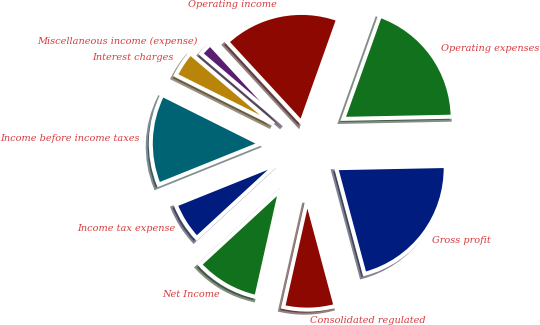<chart> <loc_0><loc_0><loc_500><loc_500><pie_chart><fcel>Gross profit<fcel>Operating expenses<fcel>Operating income<fcel>Miscellaneous income (expense)<fcel>Interest charges<fcel>Income before income taxes<fcel>Income tax expense<fcel>Net Income<fcel>Consolidated regulated<nl><fcel>21.15%<fcel>19.23%<fcel>17.31%<fcel>1.92%<fcel>3.85%<fcel>13.46%<fcel>5.77%<fcel>9.62%<fcel>7.69%<nl></chart> 